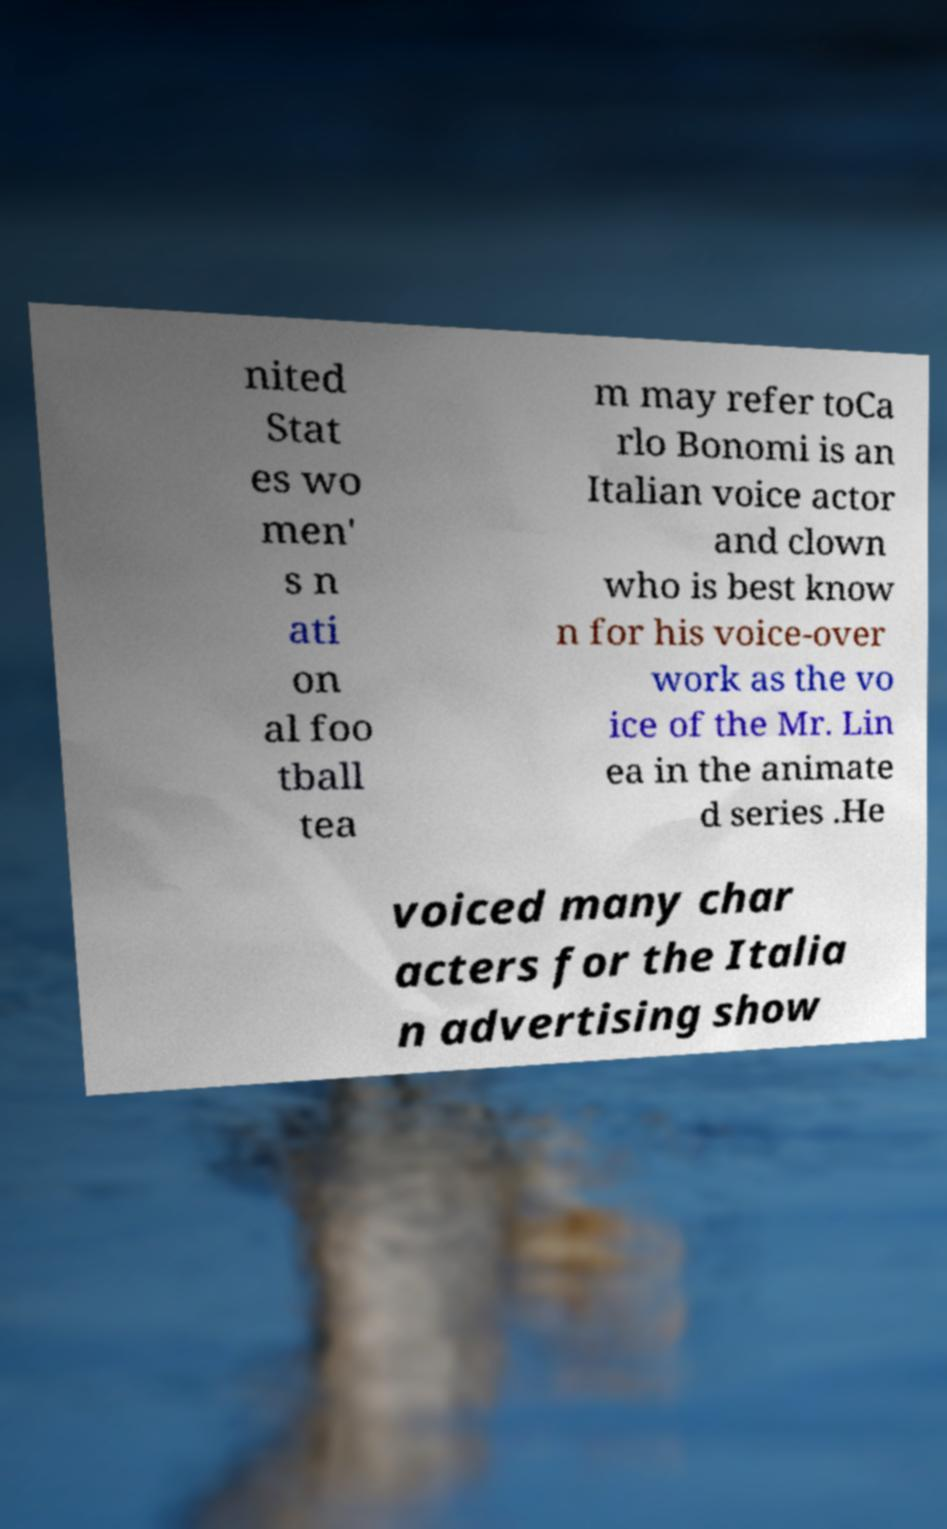Please read and relay the text visible in this image. What does it say? nited Stat es wo men' s n ati on al foo tball tea m may refer toCa rlo Bonomi is an Italian voice actor and clown who is best know n for his voice-over work as the vo ice of the Mr. Lin ea in the animate d series .He voiced many char acters for the Italia n advertising show 